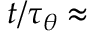<formula> <loc_0><loc_0><loc_500><loc_500>t / \tau _ { \theta } \approx</formula> 